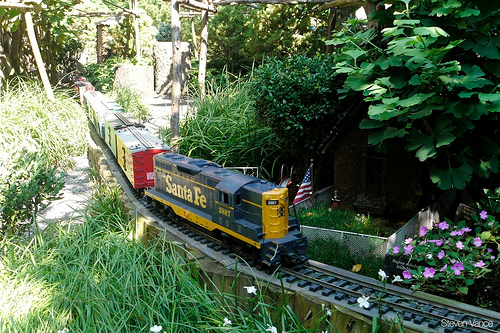What is the overall theme of this image? The overall theme of the image appears to be a miniature train set within a beautifully landscaped garden. The train, marked 'Santa Fe', is moving through lush greenery, showcasing a blend of human engineering and natural beauty. What details can you tell about the train in the image? The train in the image is adorned with the 'Santa Fe' logo, suggesting it is modeled after the famous Santa Fe Railway. The engine is primarily black and yellow, and it pulls several colorful cars, including a red and yellow one. The train is on a small track that winds through a garden setting with plants, flowers, and small structures, adding to its realism. Imagine the miniature train had a special feature. What could it be, and how would it enhance the scene? Imagine the miniature train had a built-in audio system that played realistic train sounds and occasional whistles. As the train moves along the tracks, the sound would add an immersive layer to the experience, making viewers feel they are right beside a bustling railroad. In addition, tiny LED lights could illuminate the train at night, casting beautiful and dynamic lighting effects across the garden, creating an enchanting night-time spectacle. 